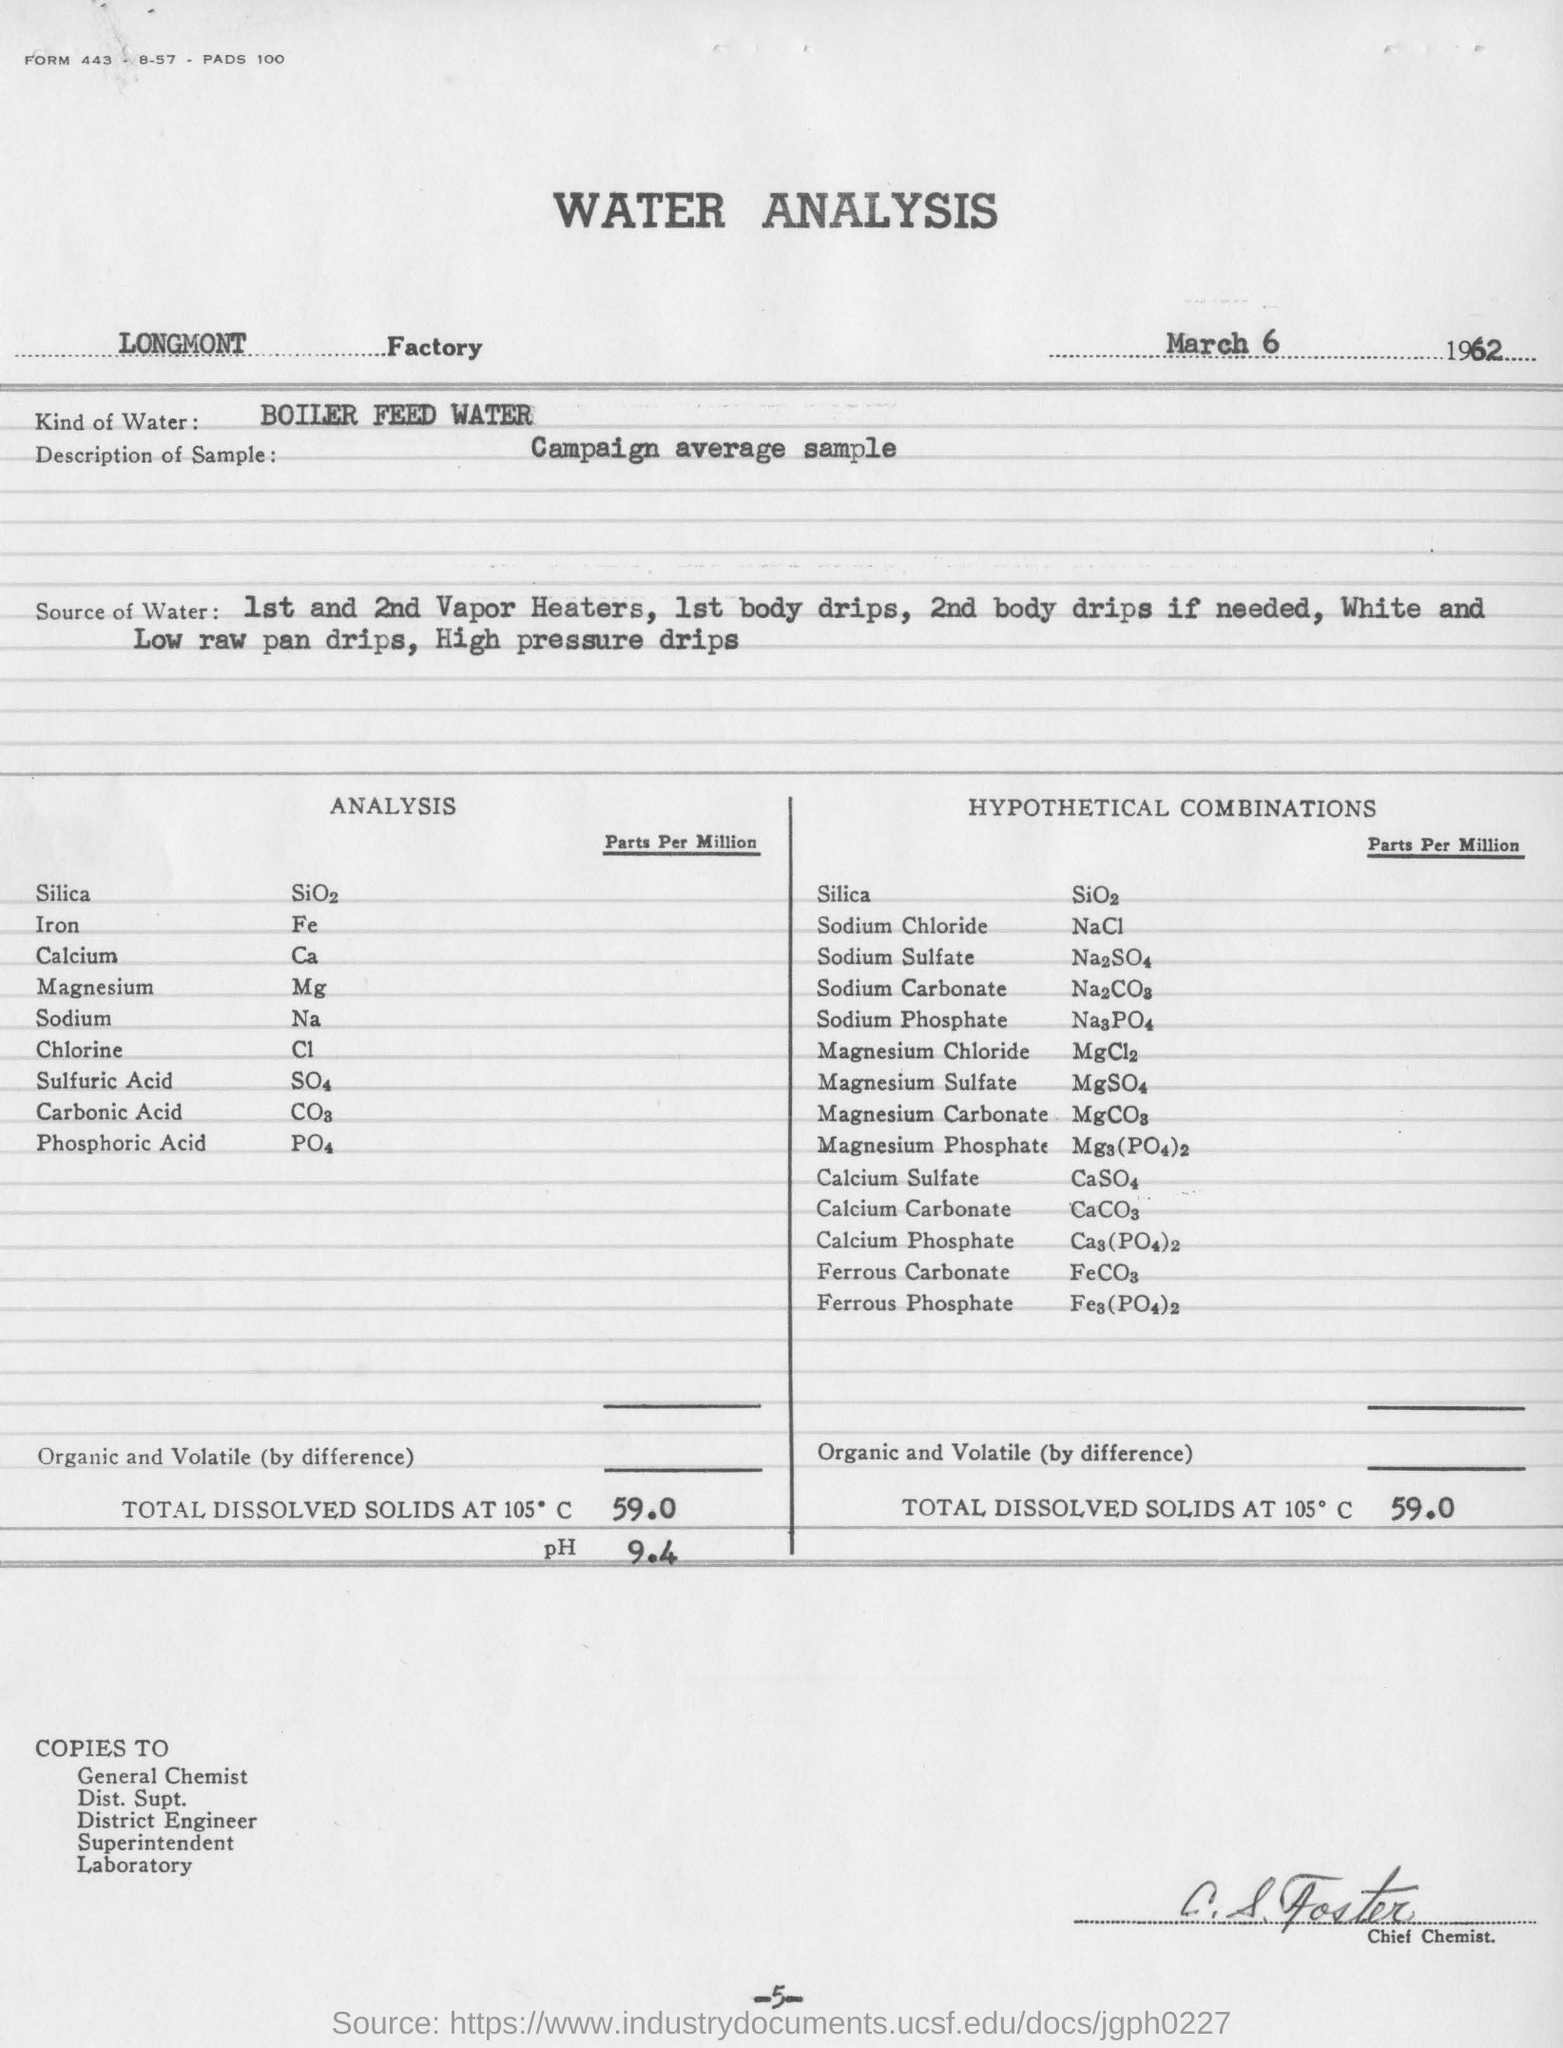Specify some key components in this picture. The page number mentioned in this document is -5-. The undersigned designates the person as the Chief Chemist. The water used for the analysis is boiler feed water. The analysis was conducted at the LONGMONT Factory. The water analysis campaign sample was taken from the average of the campaign, and the description of the sample is unknown. 